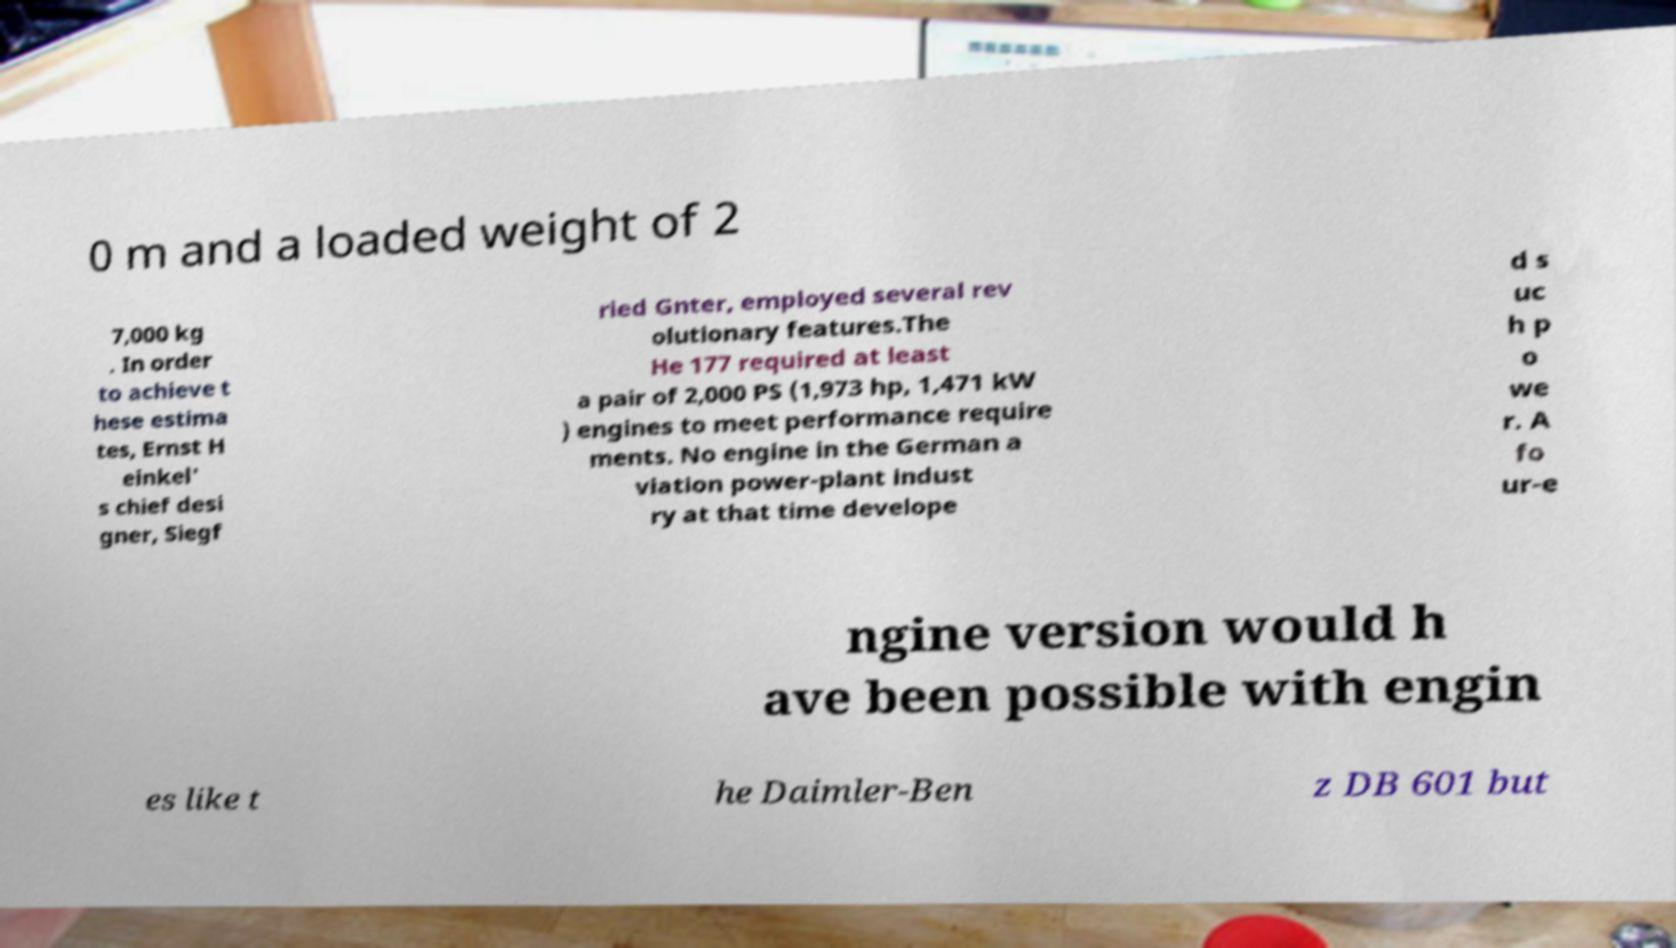There's text embedded in this image that I need extracted. Can you transcribe it verbatim? 0 m and a loaded weight of 2 7,000 kg . In order to achieve t hese estima tes, Ernst H einkel' s chief desi gner, Siegf ried Gnter, employed several rev olutionary features.The He 177 required at least a pair of 2,000 PS (1,973 hp, 1,471 kW ) engines to meet performance require ments. No engine in the German a viation power-plant indust ry at that time develope d s uc h p o we r. A fo ur-e ngine version would h ave been possible with engin es like t he Daimler-Ben z DB 601 but 